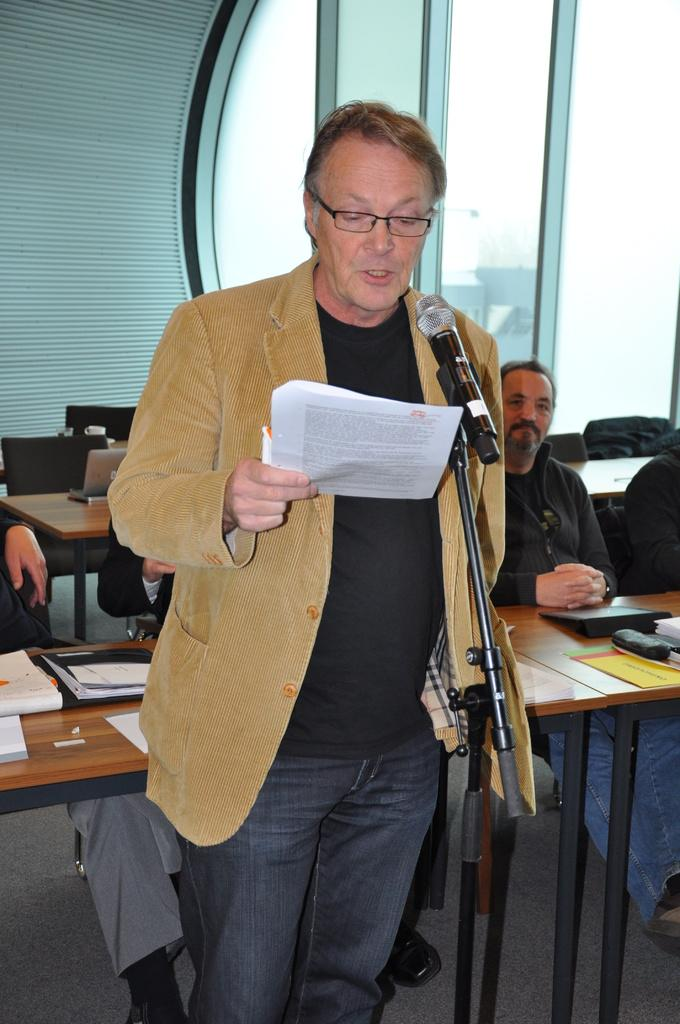What is the man in the image doing? The man is standing in the image and speaking into a microphone. What is the man holding in his hand? The man is holding a paper in his hand. What are the people in the image doing? The people are sitting at tables and listening to the man. What might the man be using the paper for? The man might be using the paper as a reference or a speech he is delivering. What level of sleep is the man in the image experiencing? There is no indication of the man's sleep level in the image, as he is standing and speaking into a microphone. Can you describe the picture hanging on the wall in the image? There is no mention of a picture hanging on the wall in the provided facts, so we cannot describe it. 